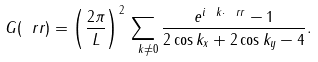Convert formula to latex. <formula><loc_0><loc_0><loc_500><loc_500>G ( \ r r ) = \left ( \frac { 2 \pi } { L } \right ) ^ { 2 } \sum _ { \ k \neq 0 } \frac { e ^ { i \ k \cdot \ r r } - 1 } { 2 \cos k _ { x } + 2 \cos k _ { y } - 4 } .</formula> 